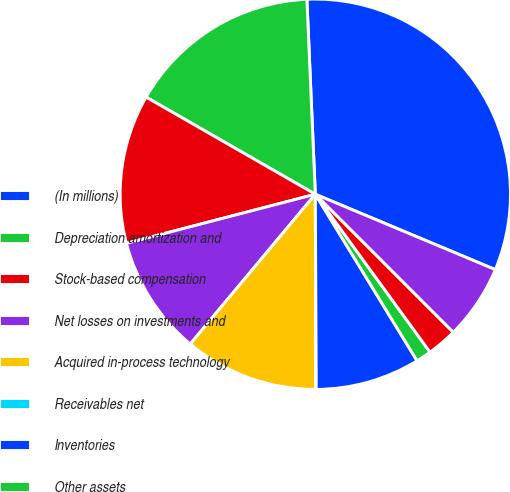<chart> <loc_0><loc_0><loc_500><loc_500><pie_chart><fcel>(In millions)<fcel>Depreciation amortization and<fcel>Stock-based compensation<fcel>Net losses on investments and<fcel>Acquired in-process technology<fcel>Receivables net<fcel>Inventories<fcel>Other assets<fcel>Accounts payable<fcel>Accrued and other liabilities<nl><fcel>32.0%<fcel>16.02%<fcel>12.34%<fcel>9.88%<fcel>11.11%<fcel>0.04%<fcel>8.65%<fcel>1.27%<fcel>2.5%<fcel>6.19%<nl></chart> 